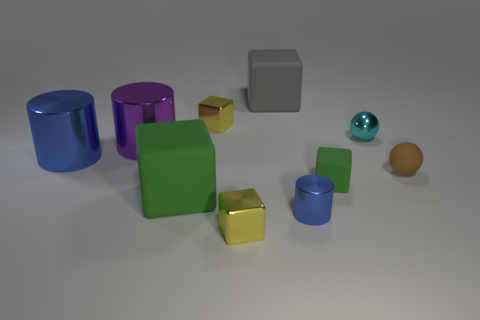Subtract all large purple shiny cylinders. How many cylinders are left? 2 Subtract all purple cylinders. How many cylinders are left? 2 Subtract all cylinders. How many objects are left? 7 Subtract 5 cubes. How many cubes are left? 0 Subtract all red cylinders. How many cyan blocks are left? 0 Add 3 purple cylinders. How many purple cylinders are left? 4 Add 6 large brown matte objects. How many large brown matte objects exist? 6 Subtract 0 cyan blocks. How many objects are left? 10 Subtract all green cylinders. Subtract all red cubes. How many cylinders are left? 3 Subtract all large purple cylinders. Subtract all cyan objects. How many objects are left? 8 